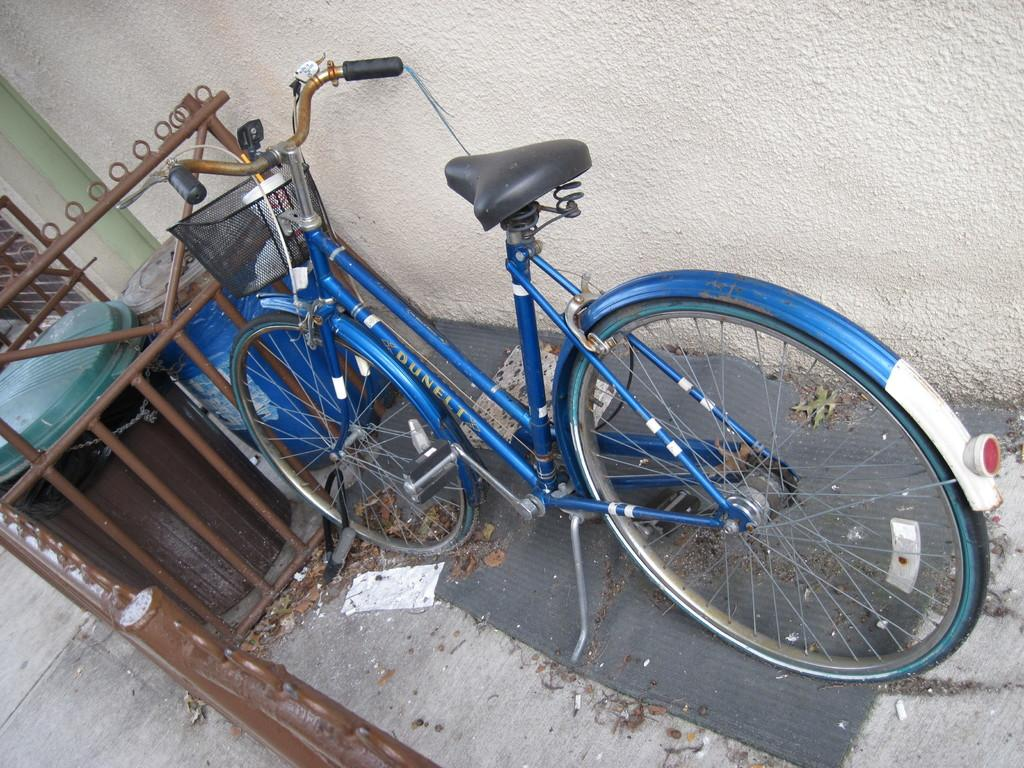What type of vehicle is in the image? There is a blue bicycle in the image. What is surrounding the bicycle? There is a brown colored railing around the bicycle. How many bins are in the image? There are two bins in the image. What color is the wall in the image? There is a cream-colored wall in the image. Where is the shelf located in the image? There is no shelf present in the image. What type of meeting is taking place in the image? There is no meeting taking place in the image. 